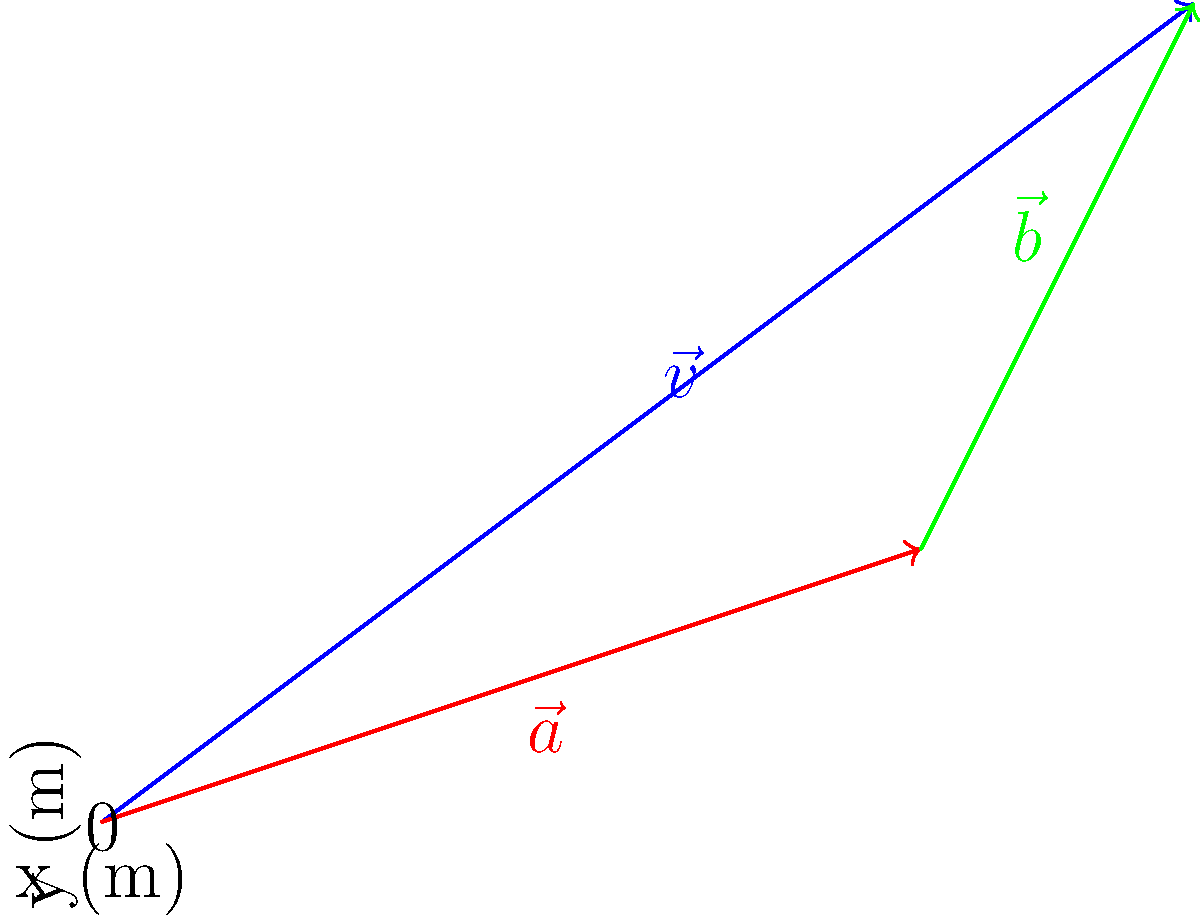In your latest avant-garde performance piece, you're creating a paint splatter artwork. You launch paint from point (0,0) with an initial velocity vector $\vec{v} = 8\hat{i} + 6\hat{j}$ (in m/s). Due to an unexpected gust of wind, the paint experiences an acceleration vector $\vec{a} = 6\hat{i} + 2\hat{j}$ (in m/s²) for 1 second. What is the final displacement vector $\vec{b}$ of the paint splatter from its initial position? Let's approach this step-by-step:

1) First, we need to calculate the displacement due to the initial velocity:
   $\vec{s_1} = \vec{v} \cdot t = (8\hat{i} + 6\hat{j}) \cdot 1\text{s} = 8\hat{i} + 6\hat{j}$ m

2) Next, we calculate the displacement due to acceleration:
   $\vec{s_2} = \frac{1}{2}\vec{a} \cdot t^2 = \frac{1}{2}(6\hat{i} + 2\hat{j}) \cdot (1\text{s})^2 = 3\hat{i} + 1\hat{j}$ m

3) The final displacement $\vec{b}$ is the sum of these two displacements:
   $\vec{b} = \vec{s_1} + \vec{s_2} = (8\hat{i} + 6\hat{j}) + (3\hat{i} + 1\hat{j}) = 11\hat{i} + 7\hat{j}$ m

4) We can express this as a single vector:
   $\vec{b} = 11\hat{i} + 7\hat{j}$ m

This matches the green vector in the diagram, representing the final displacement of the paint splatter.
Answer: $11\hat{i} + 7\hat{j}$ m 